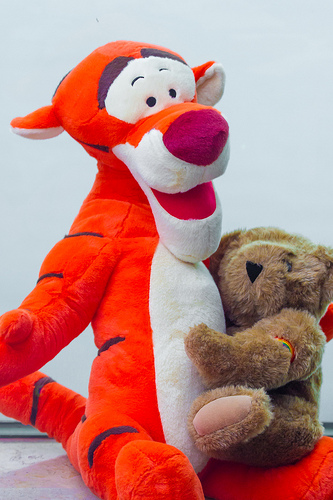<image>
Is the teddy on the tiger? Yes. Looking at the image, I can see the teddy is positioned on top of the tiger, with the tiger providing support. 